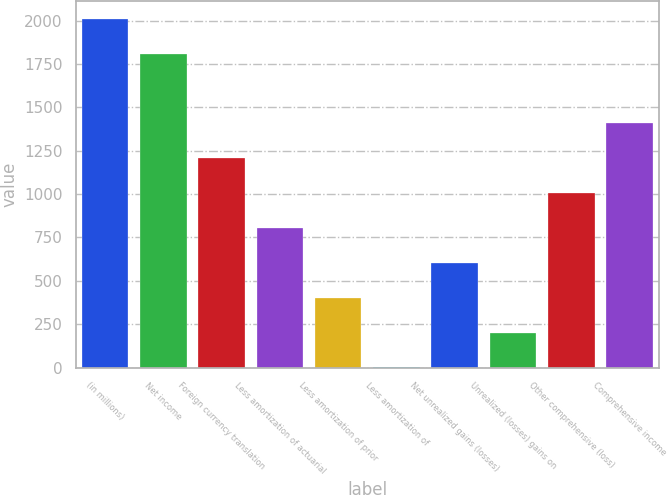Convert chart. <chart><loc_0><loc_0><loc_500><loc_500><bar_chart><fcel>(in millions)<fcel>Net income<fcel>Foreign currency translation<fcel>Less amortization of actuarial<fcel>Less amortization of prior<fcel>Less amortization of<fcel>Net unrealized gains (losses)<fcel>Unrealized (losses) gains on<fcel>Other comprehensive (loss)<fcel>Comprehensive income<nl><fcel>2010<fcel>1809.01<fcel>1206.04<fcel>804.06<fcel>402.08<fcel>0.1<fcel>603.07<fcel>201.09<fcel>1005.05<fcel>1407.03<nl></chart> 